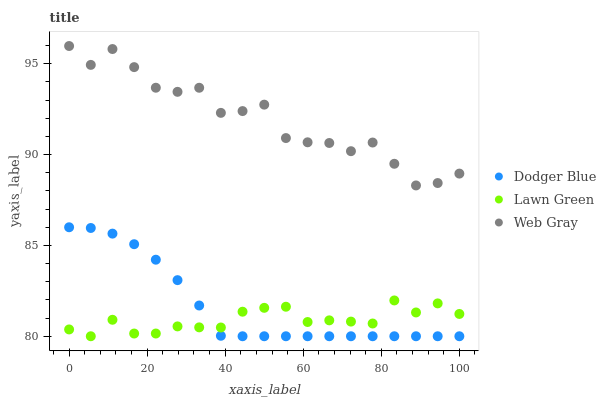Does Lawn Green have the minimum area under the curve?
Answer yes or no. Yes. Does Web Gray have the maximum area under the curve?
Answer yes or no. Yes. Does Dodger Blue have the minimum area under the curve?
Answer yes or no. No. Does Dodger Blue have the maximum area under the curve?
Answer yes or no. No. Is Dodger Blue the smoothest?
Answer yes or no. Yes. Is Web Gray the roughest?
Answer yes or no. Yes. Is Web Gray the smoothest?
Answer yes or no. No. Is Dodger Blue the roughest?
Answer yes or no. No. Does Lawn Green have the lowest value?
Answer yes or no. Yes. Does Web Gray have the lowest value?
Answer yes or no. No. Does Web Gray have the highest value?
Answer yes or no. Yes. Does Dodger Blue have the highest value?
Answer yes or no. No. Is Dodger Blue less than Web Gray?
Answer yes or no. Yes. Is Web Gray greater than Lawn Green?
Answer yes or no. Yes. Does Lawn Green intersect Dodger Blue?
Answer yes or no. Yes. Is Lawn Green less than Dodger Blue?
Answer yes or no. No. Is Lawn Green greater than Dodger Blue?
Answer yes or no. No. Does Dodger Blue intersect Web Gray?
Answer yes or no. No. 